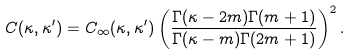Convert formula to latex. <formula><loc_0><loc_0><loc_500><loc_500>C ( \kappa , \kappa ^ { \prime } ) = C _ { \infty } ( \kappa , \kappa ^ { \prime } ) \left ( \frac { \Gamma ( \kappa - 2 m ) \Gamma ( m + 1 ) } { \Gamma ( \kappa - m ) \Gamma ( 2 m + 1 ) } \right ) ^ { 2 } .</formula> 